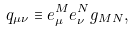<formula> <loc_0><loc_0><loc_500><loc_500>q _ { \mu \nu } \equiv e ^ { M } _ { \mu } e ^ { N } _ { \nu } g _ { M N } ,</formula> 